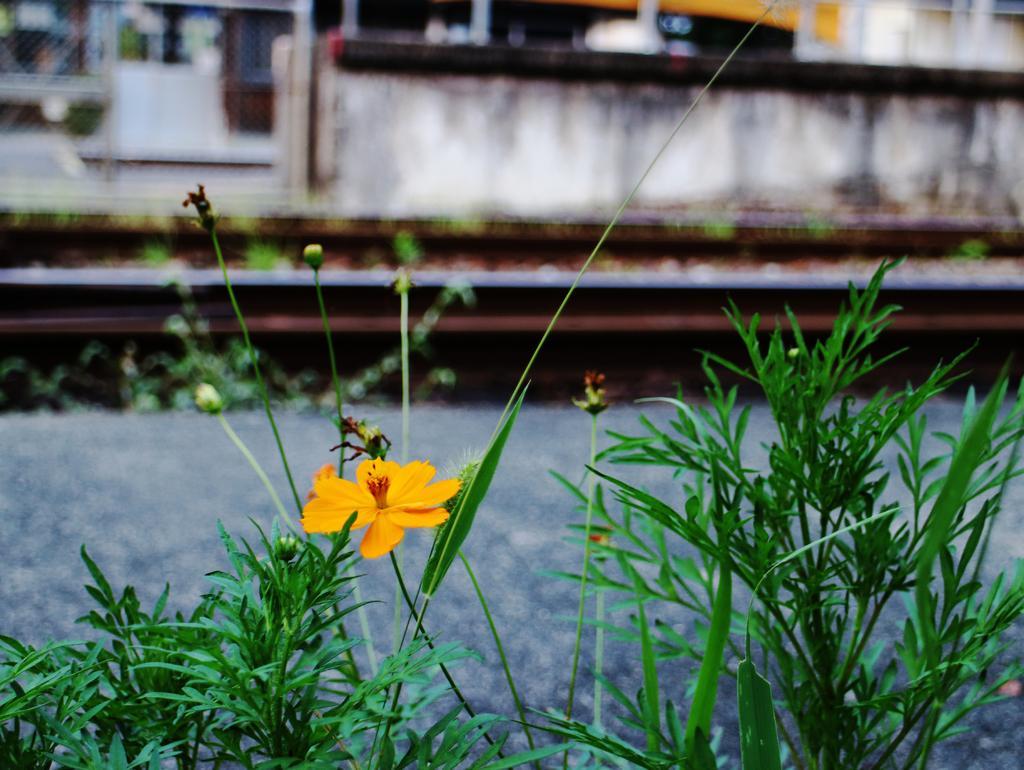Describe this image in one or two sentences. In this picture we can see some flowers in the plant, beside we can see the wall. 